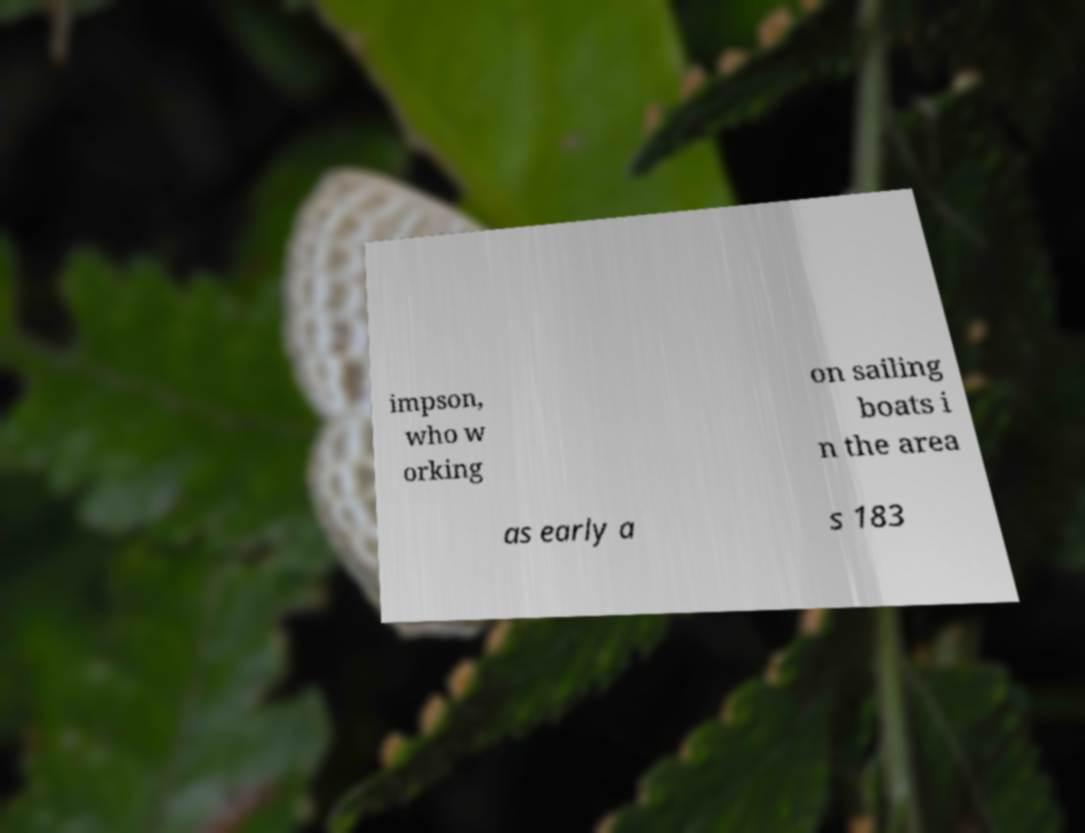Could you extract and type out the text from this image? impson, who w orking on sailing boats i n the area as early a s 183 